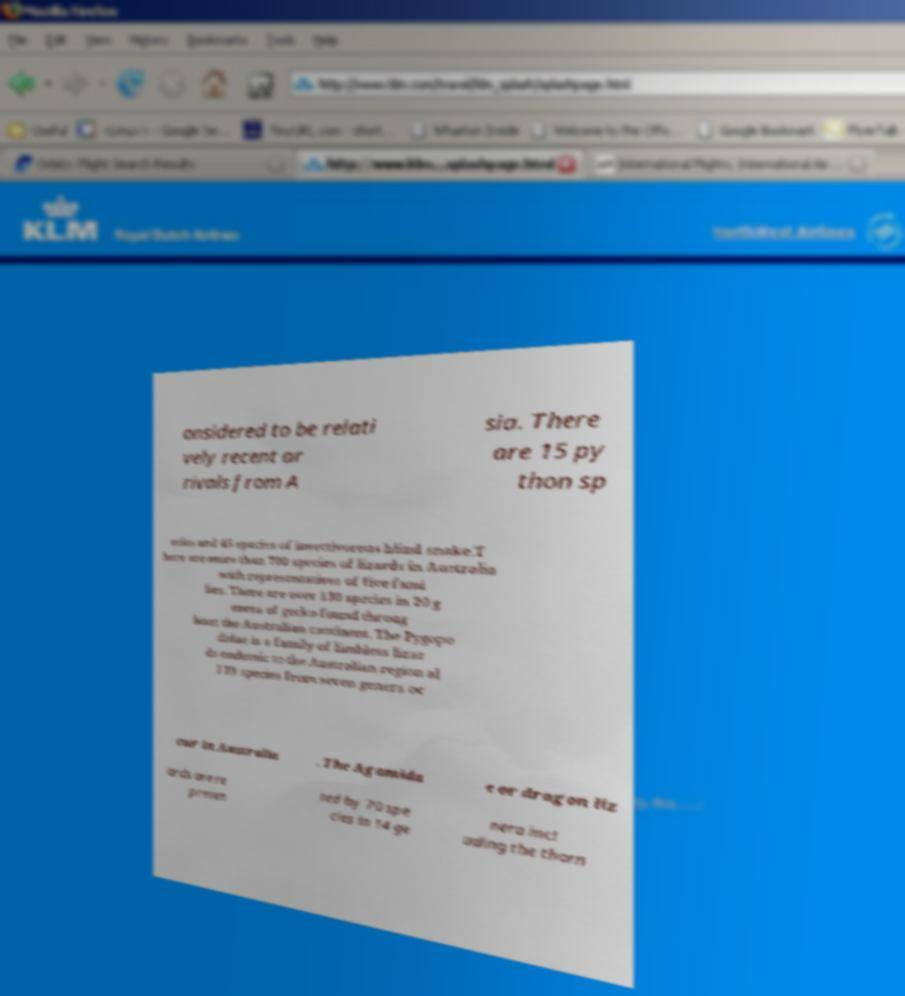For documentation purposes, I need the text within this image transcribed. Could you provide that? onsidered to be relati vely recent ar rivals from A sia. There are 15 py thon sp ecies and 45 species of insectivorous blind snake.T here are more than 700 species of lizards in Australia with representatives of five fami lies. There are over 130 species in 20 g enera of gecko found throug hout the Australian continent. The Pygopo didae is a family of limbless lizar ds endemic to the Australian region al l 39 species from seven genera oc cur in Australia . The Agamida e or dragon liz ards are re presen ted by 70 spe cies in 14 ge nera incl uding the thorn 